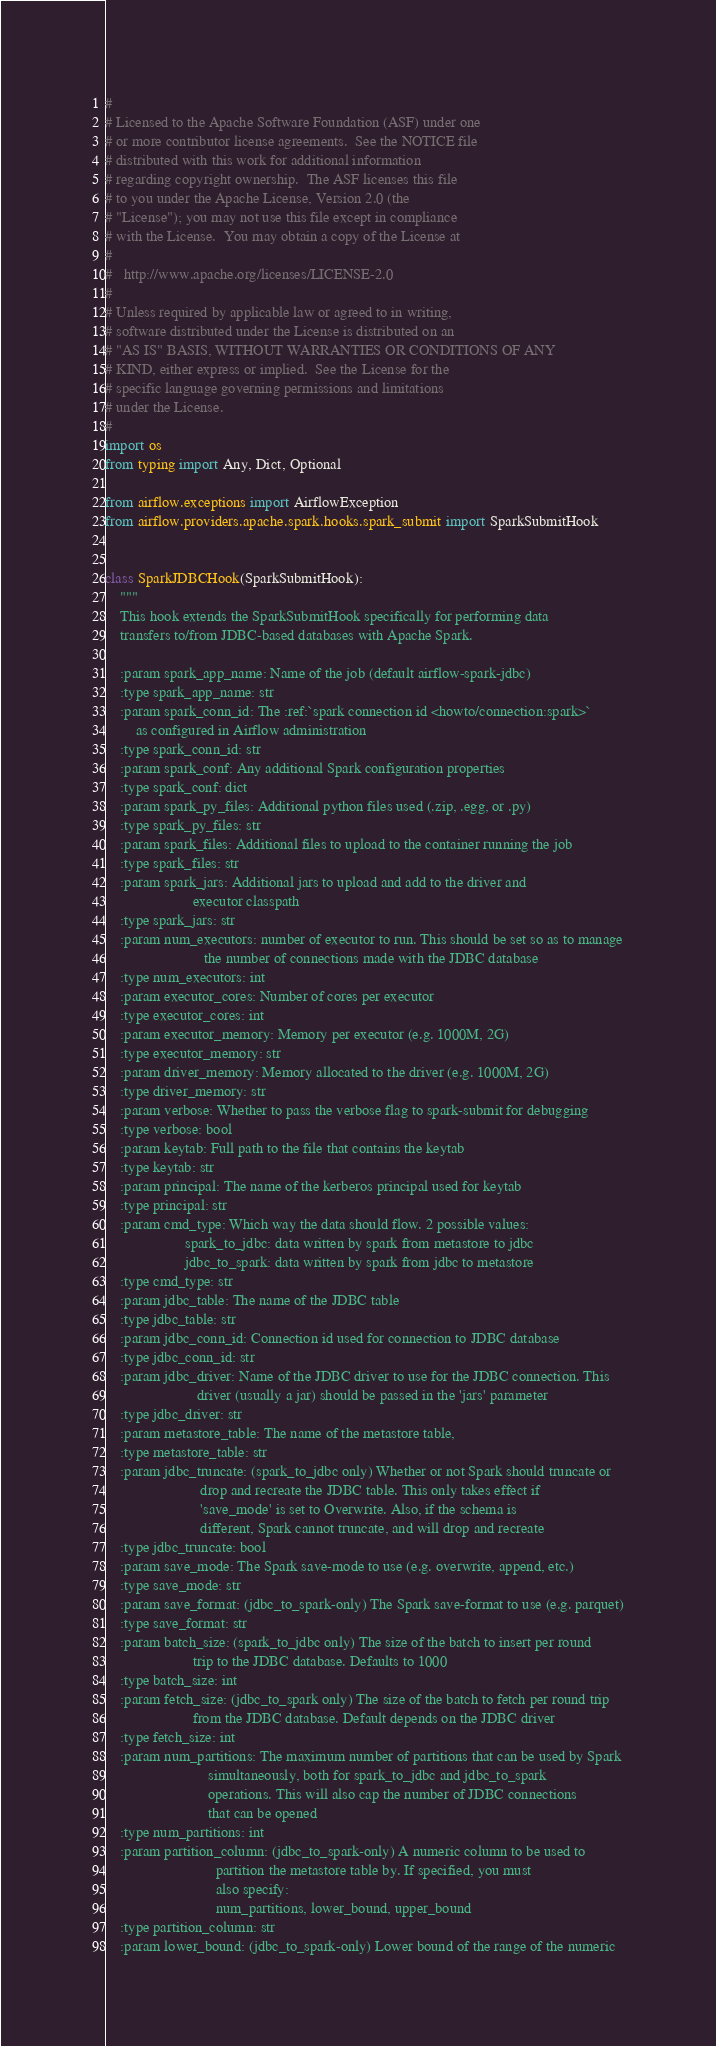Convert code to text. <code><loc_0><loc_0><loc_500><loc_500><_Python_>#
# Licensed to the Apache Software Foundation (ASF) under one
# or more contributor license agreements.  See the NOTICE file
# distributed with this work for additional information
# regarding copyright ownership.  The ASF licenses this file
# to you under the Apache License, Version 2.0 (the
# "License"); you may not use this file except in compliance
# with the License.  You may obtain a copy of the License at
#
#   http://www.apache.org/licenses/LICENSE-2.0
#
# Unless required by applicable law or agreed to in writing,
# software distributed under the License is distributed on an
# "AS IS" BASIS, WITHOUT WARRANTIES OR CONDITIONS OF ANY
# KIND, either express or implied.  See the License for the
# specific language governing permissions and limitations
# under the License.
#
import os
from typing import Any, Dict, Optional

from airflow.exceptions import AirflowException
from airflow.providers.apache.spark.hooks.spark_submit import SparkSubmitHook


class SparkJDBCHook(SparkSubmitHook):
    """
    This hook extends the SparkSubmitHook specifically for performing data
    transfers to/from JDBC-based databases with Apache Spark.

    :param spark_app_name: Name of the job (default airflow-spark-jdbc)
    :type spark_app_name: str
    :param spark_conn_id: The :ref:`spark connection id <howto/connection:spark>`
        as configured in Airflow administration
    :type spark_conn_id: str
    :param spark_conf: Any additional Spark configuration properties
    :type spark_conf: dict
    :param spark_py_files: Additional python files used (.zip, .egg, or .py)
    :type spark_py_files: str
    :param spark_files: Additional files to upload to the container running the job
    :type spark_files: str
    :param spark_jars: Additional jars to upload and add to the driver and
                       executor classpath
    :type spark_jars: str
    :param num_executors: number of executor to run. This should be set so as to manage
                          the number of connections made with the JDBC database
    :type num_executors: int
    :param executor_cores: Number of cores per executor
    :type executor_cores: int
    :param executor_memory: Memory per executor (e.g. 1000M, 2G)
    :type executor_memory: str
    :param driver_memory: Memory allocated to the driver (e.g. 1000M, 2G)
    :type driver_memory: str
    :param verbose: Whether to pass the verbose flag to spark-submit for debugging
    :type verbose: bool
    :param keytab: Full path to the file that contains the keytab
    :type keytab: str
    :param principal: The name of the kerberos principal used for keytab
    :type principal: str
    :param cmd_type: Which way the data should flow. 2 possible values:
                     spark_to_jdbc: data written by spark from metastore to jdbc
                     jdbc_to_spark: data written by spark from jdbc to metastore
    :type cmd_type: str
    :param jdbc_table: The name of the JDBC table
    :type jdbc_table: str
    :param jdbc_conn_id: Connection id used for connection to JDBC database
    :type jdbc_conn_id: str
    :param jdbc_driver: Name of the JDBC driver to use for the JDBC connection. This
                        driver (usually a jar) should be passed in the 'jars' parameter
    :type jdbc_driver: str
    :param metastore_table: The name of the metastore table,
    :type metastore_table: str
    :param jdbc_truncate: (spark_to_jdbc only) Whether or not Spark should truncate or
                         drop and recreate the JDBC table. This only takes effect if
                         'save_mode' is set to Overwrite. Also, if the schema is
                         different, Spark cannot truncate, and will drop and recreate
    :type jdbc_truncate: bool
    :param save_mode: The Spark save-mode to use (e.g. overwrite, append, etc.)
    :type save_mode: str
    :param save_format: (jdbc_to_spark-only) The Spark save-format to use (e.g. parquet)
    :type save_format: str
    :param batch_size: (spark_to_jdbc only) The size of the batch to insert per round
                       trip to the JDBC database. Defaults to 1000
    :type batch_size: int
    :param fetch_size: (jdbc_to_spark only) The size of the batch to fetch per round trip
                       from the JDBC database. Default depends on the JDBC driver
    :type fetch_size: int
    :param num_partitions: The maximum number of partitions that can be used by Spark
                           simultaneously, both for spark_to_jdbc and jdbc_to_spark
                           operations. This will also cap the number of JDBC connections
                           that can be opened
    :type num_partitions: int
    :param partition_column: (jdbc_to_spark-only) A numeric column to be used to
                             partition the metastore table by. If specified, you must
                             also specify:
                             num_partitions, lower_bound, upper_bound
    :type partition_column: str
    :param lower_bound: (jdbc_to_spark-only) Lower bound of the range of the numeric</code> 